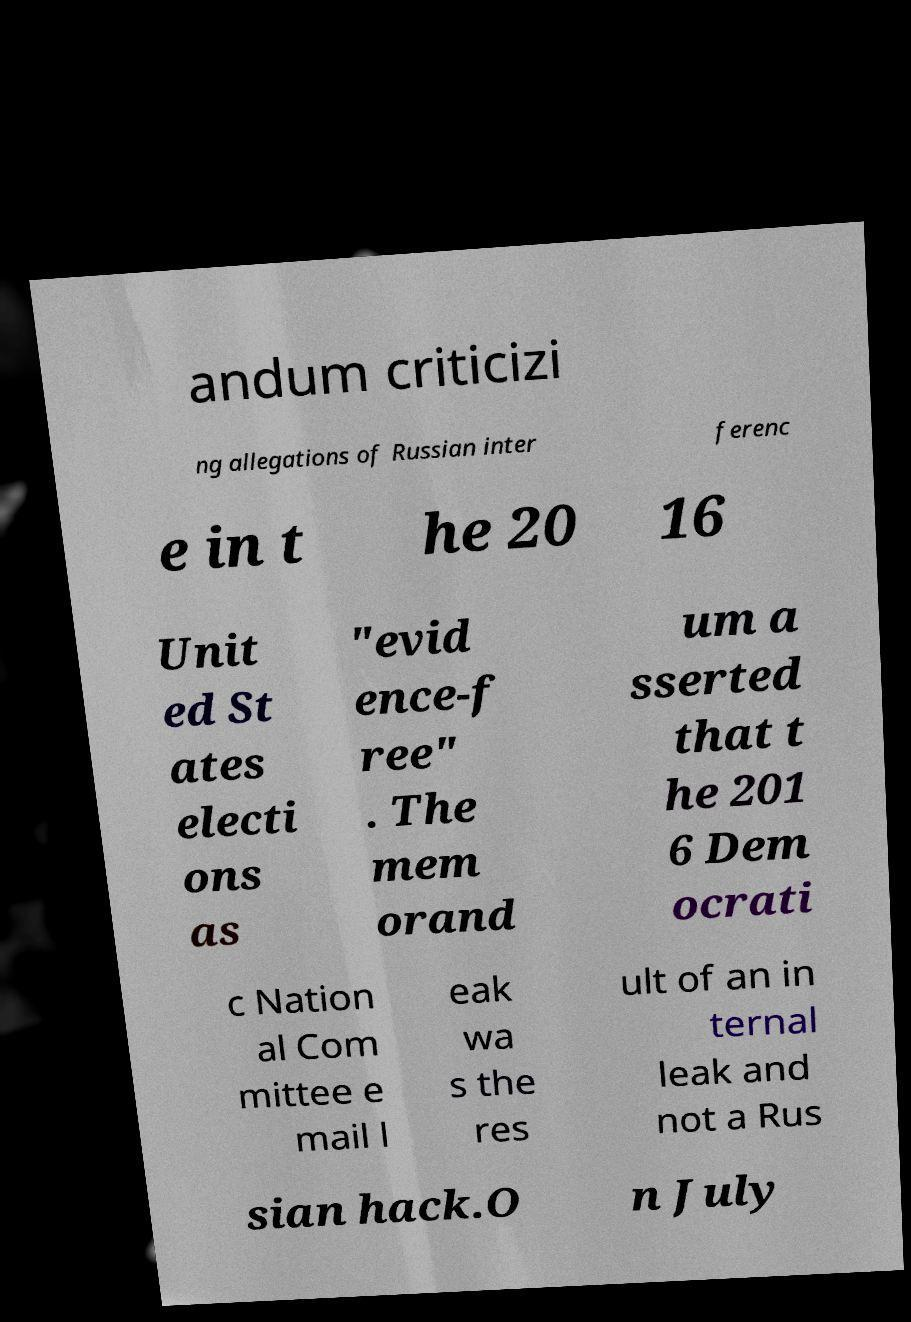For documentation purposes, I need the text within this image transcribed. Could you provide that? andum criticizi ng allegations of Russian inter ferenc e in t he 20 16 Unit ed St ates electi ons as "evid ence-f ree" . The mem orand um a sserted that t he 201 6 Dem ocrati c Nation al Com mittee e mail l eak wa s the res ult of an in ternal leak and not a Rus sian hack.O n July 